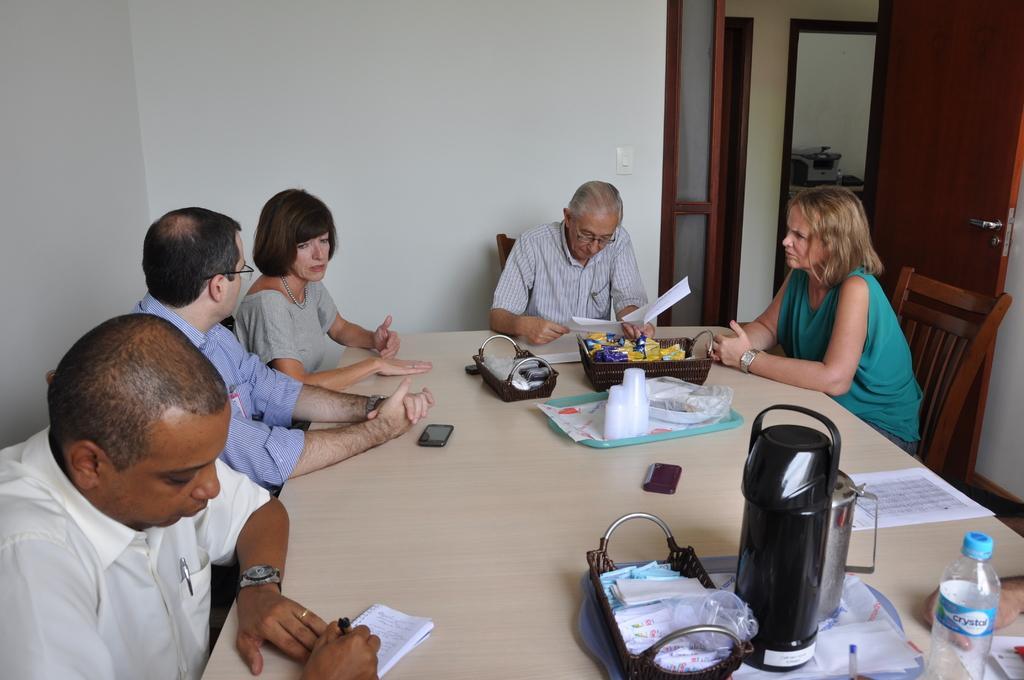How would you summarize this image in a sentence or two? This picture shows a group of people seated on the chairs and we see a man writing and a man reading and we see bottles,papers, cup on the table. 